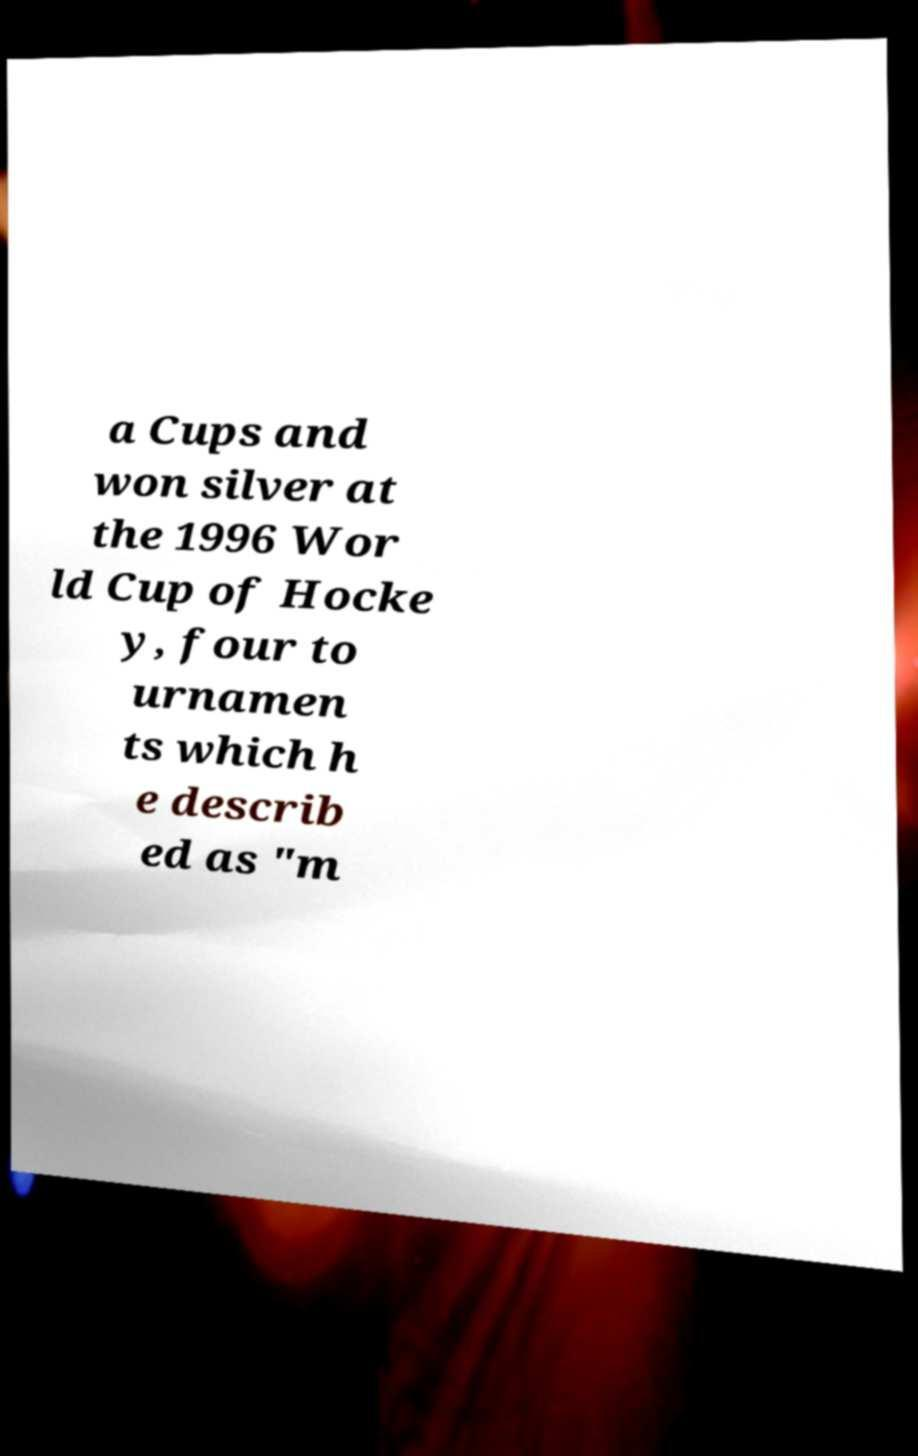Can you read and provide the text displayed in the image?This photo seems to have some interesting text. Can you extract and type it out for me? a Cups and won silver at the 1996 Wor ld Cup of Hocke y, four to urnamen ts which h e describ ed as "m 